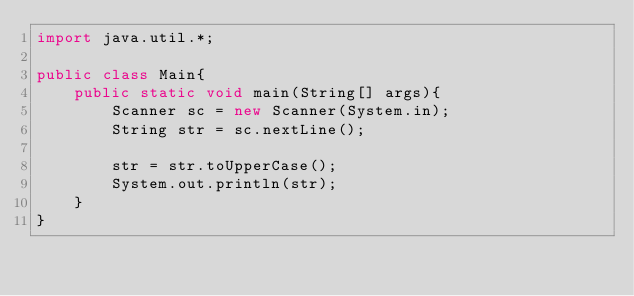Convert code to text. <code><loc_0><loc_0><loc_500><loc_500><_Java_>import java.util.*;

public class Main{
    public static void main(String[] args){
        Scanner sc = new Scanner(System.in);
        String str = sc.nextLine();

        str = str.toUpperCase();
        System.out.println(str);
    }
}
</code> 